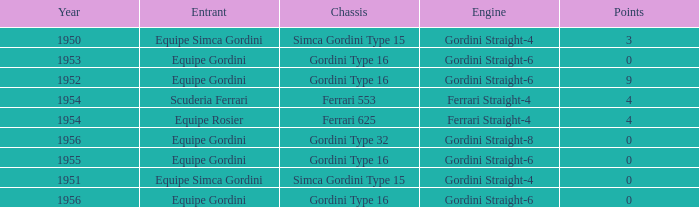What chassis has smaller than 9 points by Equipe Rosier? Ferrari 625. 